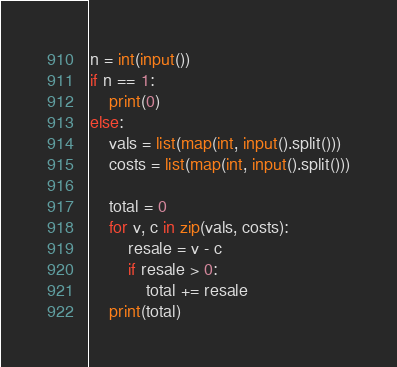<code> <loc_0><loc_0><loc_500><loc_500><_Python_>n = int(input())
if n == 1:
	print(0)
else:
	vals = list(map(int, input().split()))
    costs = list(map(int, input().split()))
 
	total = 0
	for v, c in zip(vals, costs):
    	resale = v - c
        if resale > 0:
        	total += resale
    print(total)</code> 